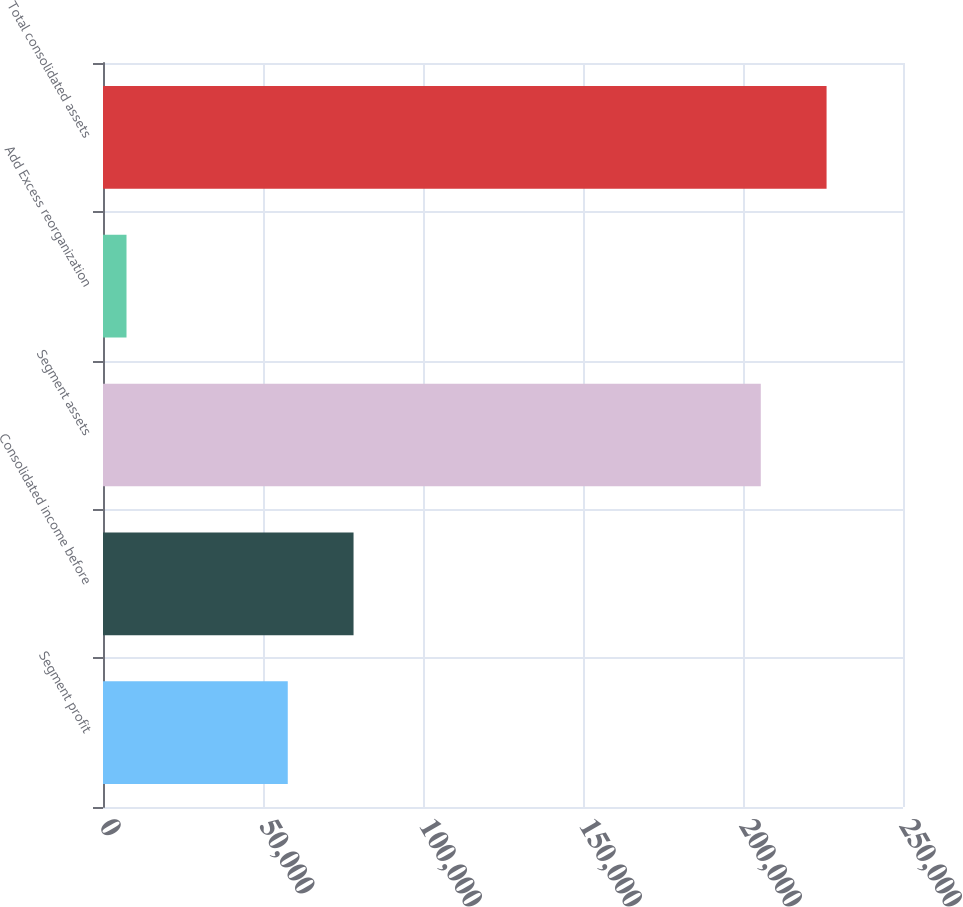<chart> <loc_0><loc_0><loc_500><loc_500><bar_chart><fcel>Segment profit<fcel>Consolidated income before<fcel>Segment assets<fcel>Add Excess reorganization<fcel>Total consolidated assets<nl><fcel>57739<fcel>78295<fcel>205560<fcel>7347<fcel>226116<nl></chart> 